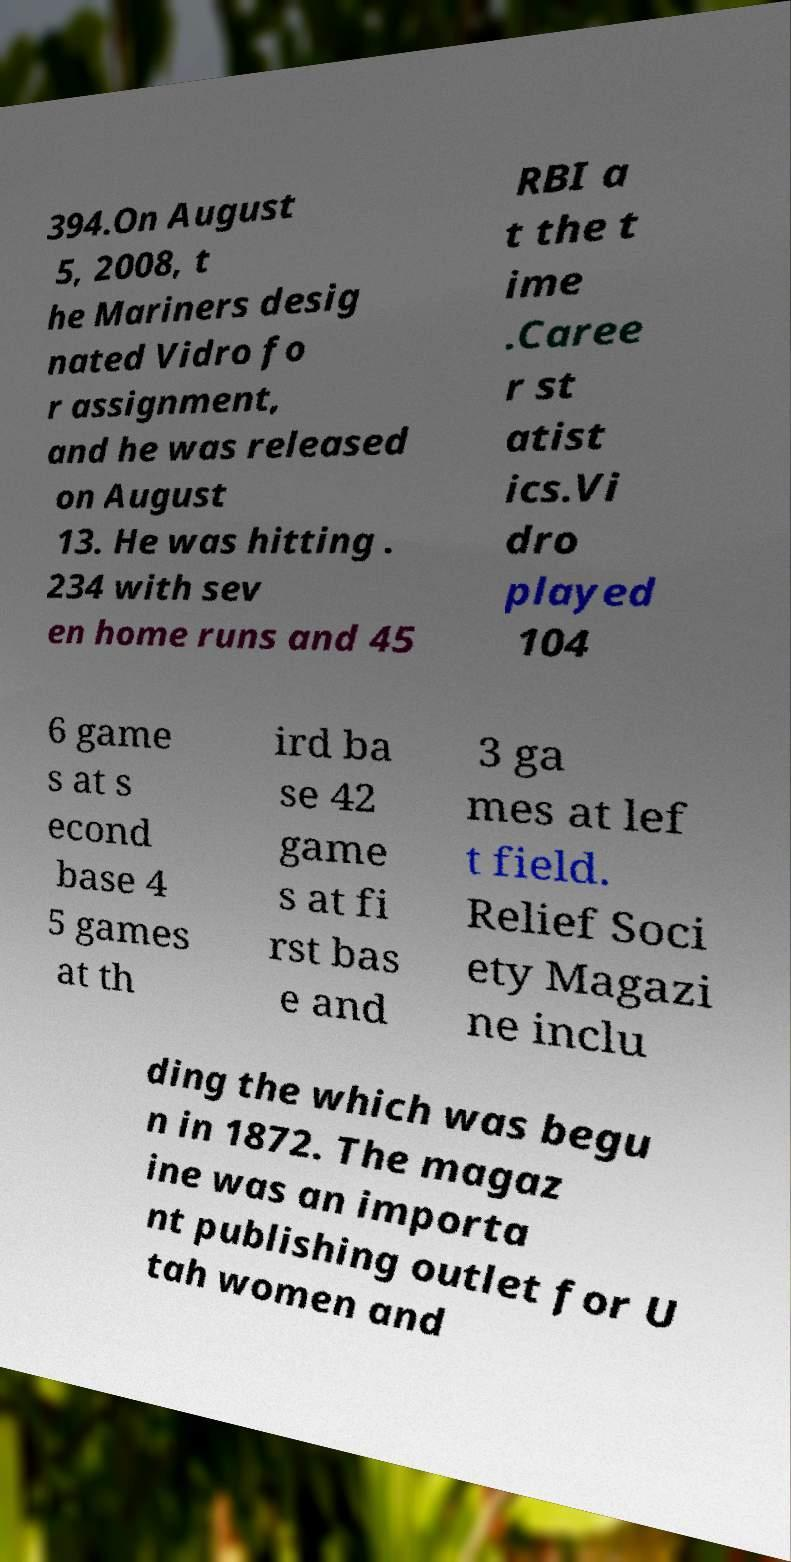Can you accurately transcribe the text from the provided image for me? 394.On August 5, 2008, t he Mariners desig nated Vidro fo r assignment, and he was released on August 13. He was hitting . 234 with sev en home runs and 45 RBI a t the t ime .Caree r st atist ics.Vi dro played 104 6 game s at s econd base 4 5 games at th ird ba se 42 game s at fi rst bas e and 3 ga mes at lef t field. Relief Soci ety Magazi ne inclu ding the which was begu n in 1872. The magaz ine was an importa nt publishing outlet for U tah women and 